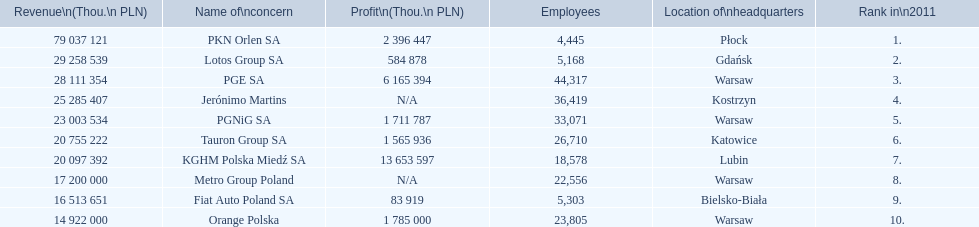What is the number of employees that work for pkn orlen sa in poland? 4,445. What number of employees work for lotos group sa? 5,168. How many people work for pgnig sa? 33,071. 